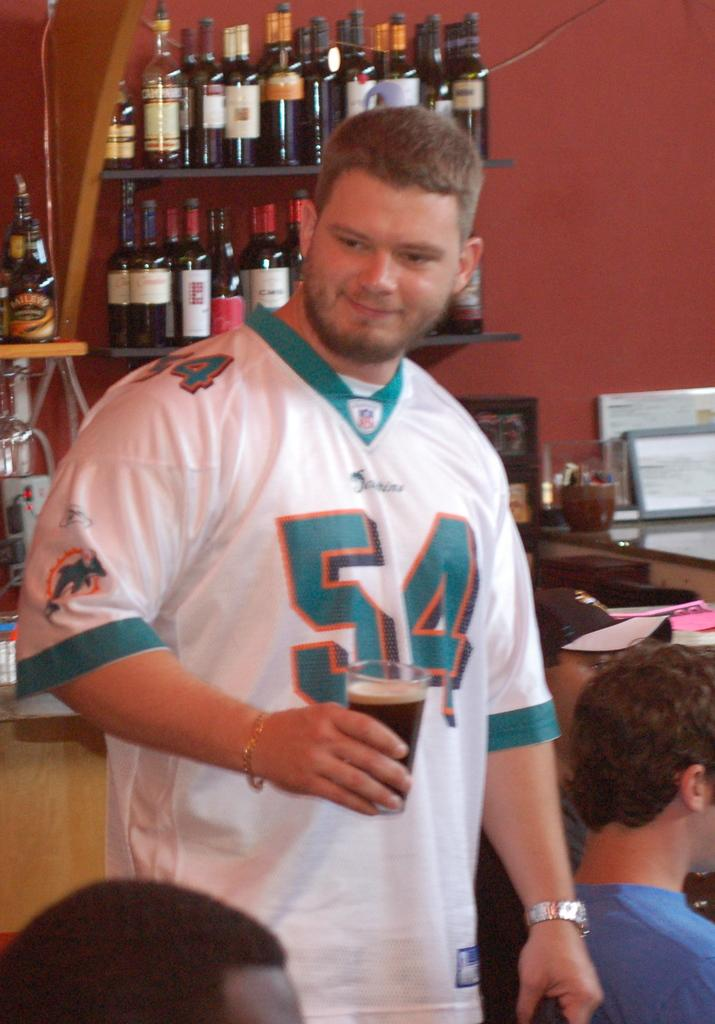<image>
Summarize the visual content of the image. guy wearing number 54 miami dolphins jersey holding bear in front of shelves of wine bottles 